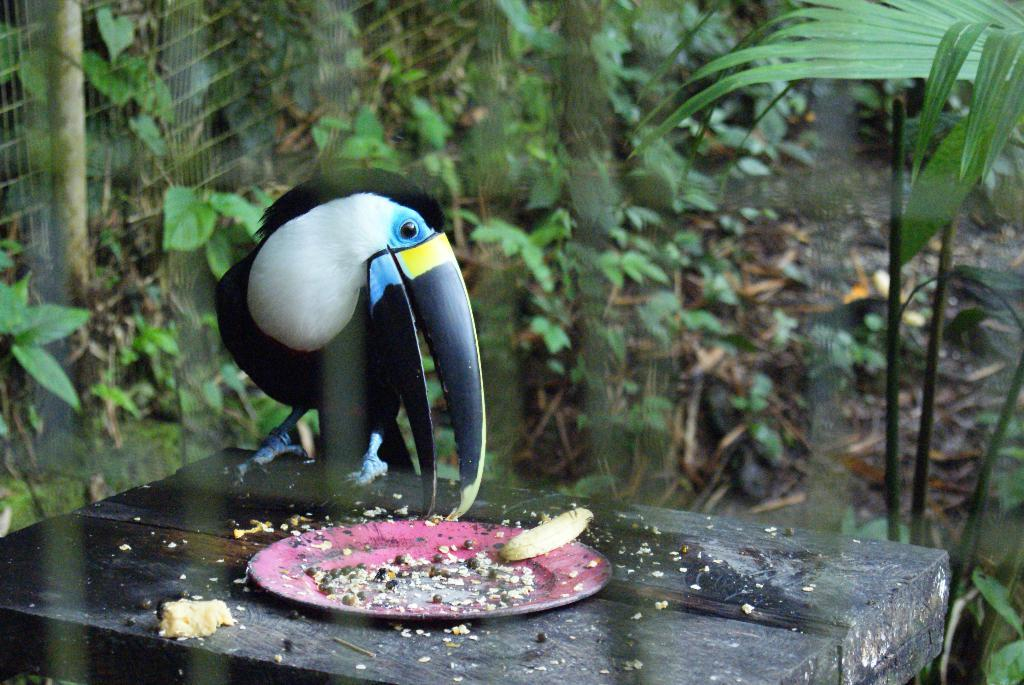What type of animal can be seen in the image? There is a bird in the image. What is the bird doing in the image? The bird is standing on an object. What might the bird be eating in the image? There is a plate with grains near the bird, which suggests it might be eating the grains. What can be seen in the background of the image? There are plants visible in the background of the image. What guide is the bird using to navigate in the image? There is no guide present in the image, and the bird does not appear to be navigating. 